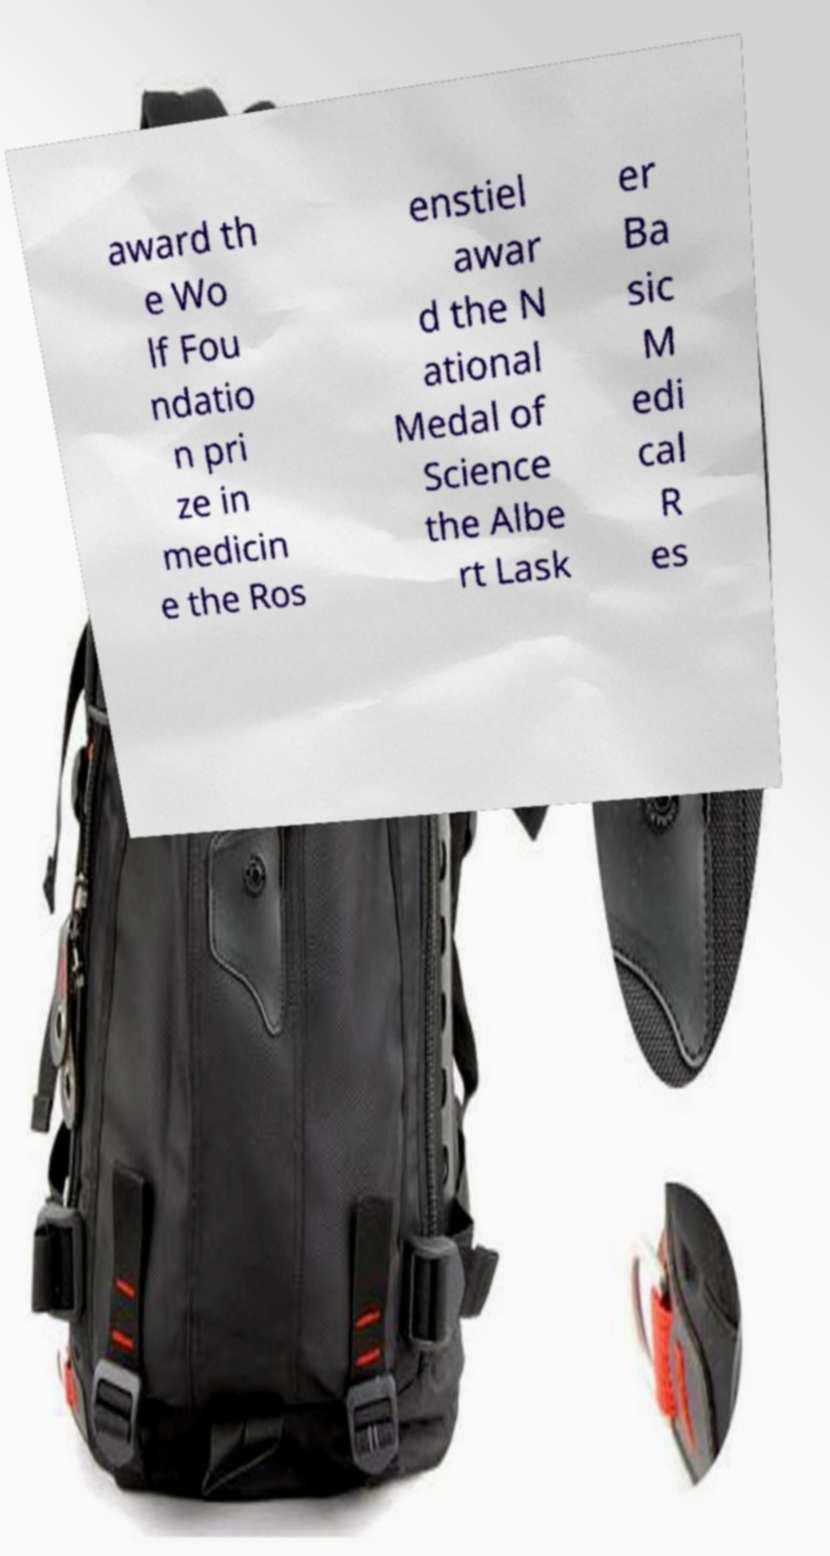There's text embedded in this image that I need extracted. Can you transcribe it verbatim? award th e Wo lf Fou ndatio n pri ze in medicin e the Ros enstiel awar d the N ational Medal of Science the Albe rt Lask er Ba sic M edi cal R es 